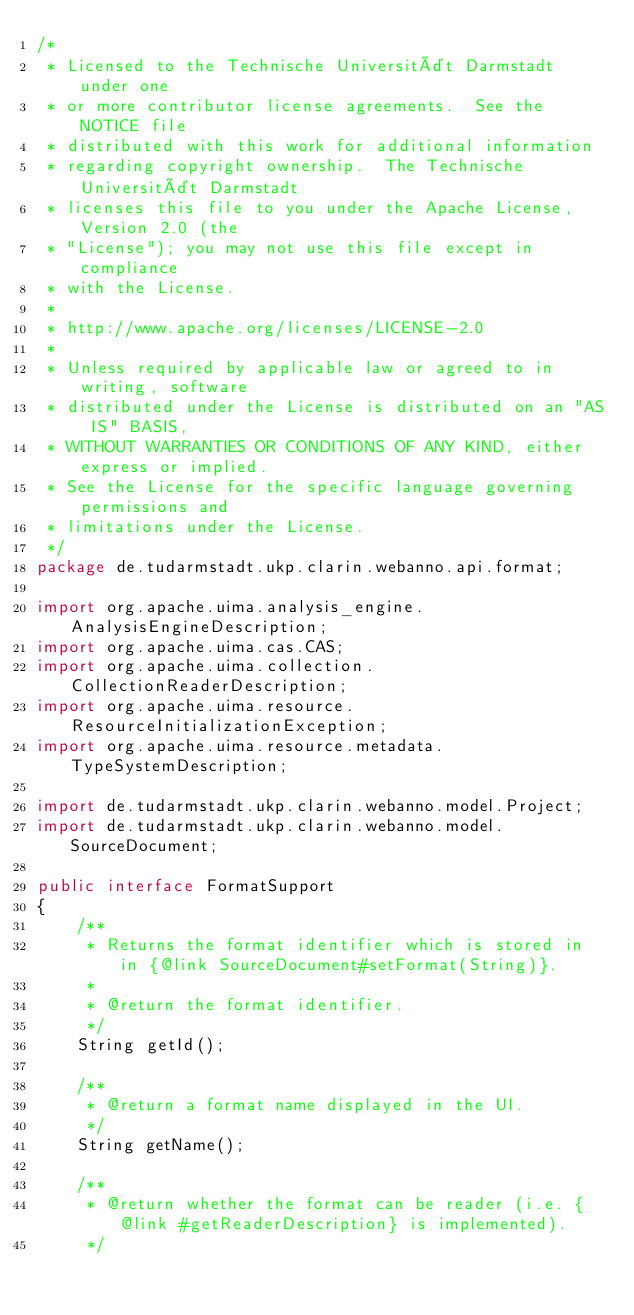Convert code to text. <code><loc_0><loc_0><loc_500><loc_500><_Java_>/*
 * Licensed to the Technische Universität Darmstadt under one
 * or more contributor license agreements.  See the NOTICE file
 * distributed with this work for additional information
 * regarding copyright ownership.  The Technische Universität Darmstadt 
 * licenses this file to you under the Apache License, Version 2.0 (the
 * "License"); you may not use this file except in compliance
 * with the License.
 *  
 * http://www.apache.org/licenses/LICENSE-2.0
 * 
 * Unless required by applicable law or agreed to in writing, software
 * distributed under the License is distributed on an "AS IS" BASIS,
 * WITHOUT WARRANTIES OR CONDITIONS OF ANY KIND, either express or implied.
 * See the License for the specific language governing permissions and
 * limitations under the License.
 */
package de.tudarmstadt.ukp.clarin.webanno.api.format;

import org.apache.uima.analysis_engine.AnalysisEngineDescription;
import org.apache.uima.cas.CAS;
import org.apache.uima.collection.CollectionReaderDescription;
import org.apache.uima.resource.ResourceInitializationException;
import org.apache.uima.resource.metadata.TypeSystemDescription;

import de.tudarmstadt.ukp.clarin.webanno.model.Project;
import de.tudarmstadt.ukp.clarin.webanno.model.SourceDocument;

public interface FormatSupport
{
    /**
     * Returns the format identifier which is stored in in {@link SourceDocument#setFormat(String)}.
     * 
     * @return the format identifier.
     */
    String getId();

    /**
     * @return a format name displayed in the UI.
     */
    String getName();

    /**
     * @return whether the format can be reader (i.e. {@link #getReaderDescription} is implemented).
     */</code> 